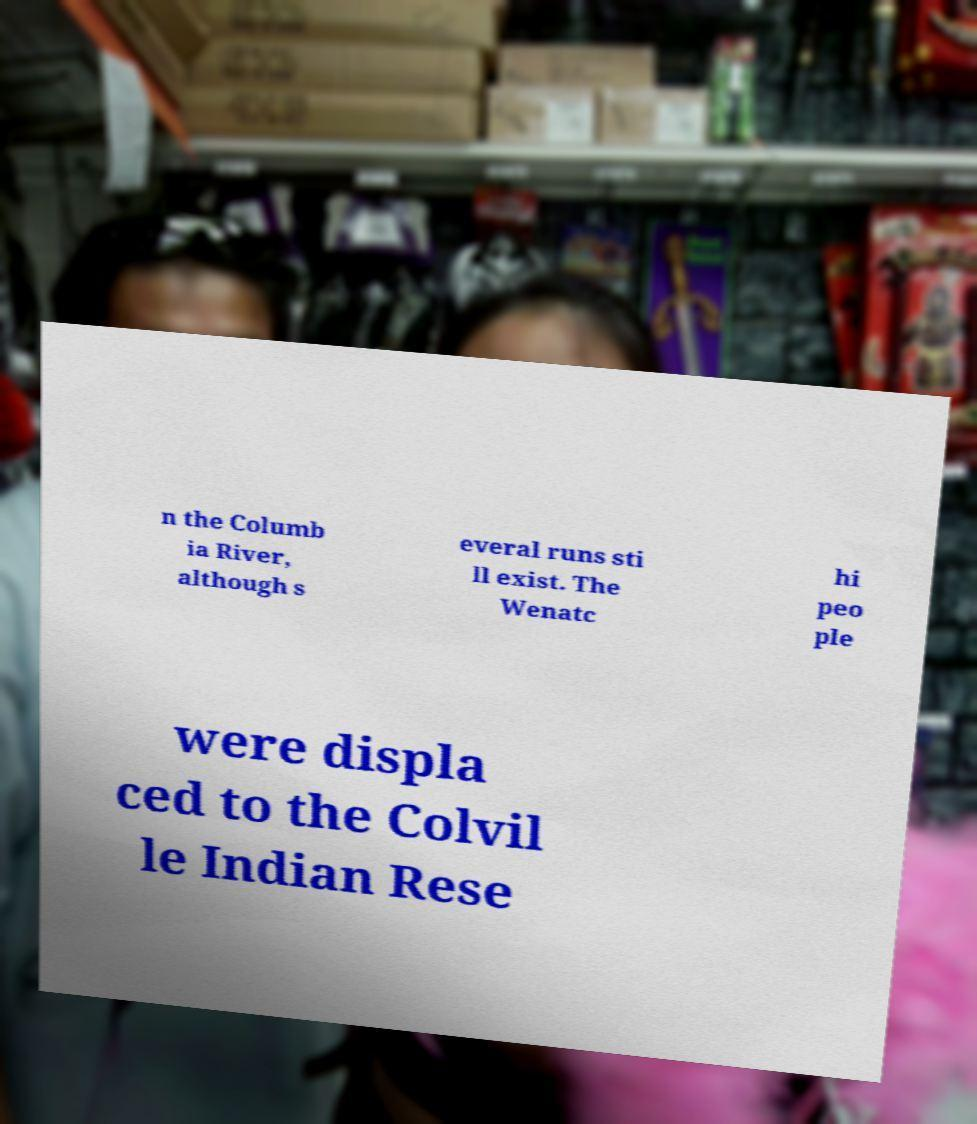There's text embedded in this image that I need extracted. Can you transcribe it verbatim? n the Columb ia River, although s everal runs sti ll exist. The Wenatc hi peo ple were displa ced to the Colvil le Indian Rese 